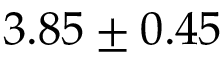<formula> <loc_0><loc_0><loc_500><loc_500>3 . 8 5 \pm 0 . 4 5</formula> 